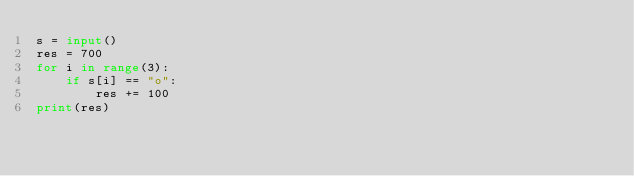Convert code to text. <code><loc_0><loc_0><loc_500><loc_500><_Python_>s = input()
res = 700
for i in range(3):
    if s[i] == "o":
        res += 100
print(res)</code> 